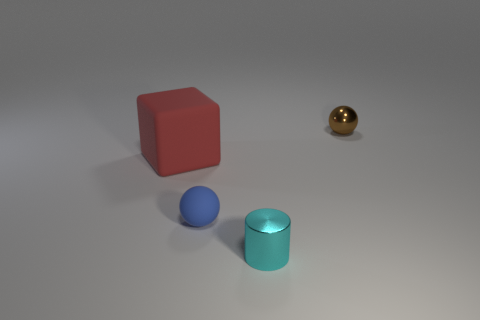What is the shape of the blue thing that is the same size as the cyan object?
Provide a short and direct response. Sphere. There is a small shiny object that is on the right side of the cyan shiny cylinder; are there any blue matte things to the right of it?
Provide a short and direct response. No. The other matte thing that is the same shape as the brown thing is what color?
Keep it short and to the point. Blue. Is the color of the tiny ball that is right of the cyan metallic cylinder the same as the tiny matte thing?
Provide a succinct answer. No. How many things are either things that are behind the red cube or cyan cylinders?
Offer a terse response. 2. The small object in front of the tiny sphere in front of the small shiny thing that is to the right of the tiny cyan shiny cylinder is made of what material?
Make the answer very short. Metal. Is the number of metal things to the right of the rubber block greater than the number of small cyan metal cylinders that are right of the blue ball?
Ensure brevity in your answer.  Yes. What number of cylinders are blue objects or shiny things?
Your answer should be compact. 1. There is a tiny metal object behind the small sphere in front of the metal ball; how many red matte things are on the left side of it?
Keep it short and to the point. 1. Is the number of red blocks greater than the number of tiny objects?
Your answer should be compact. No. 